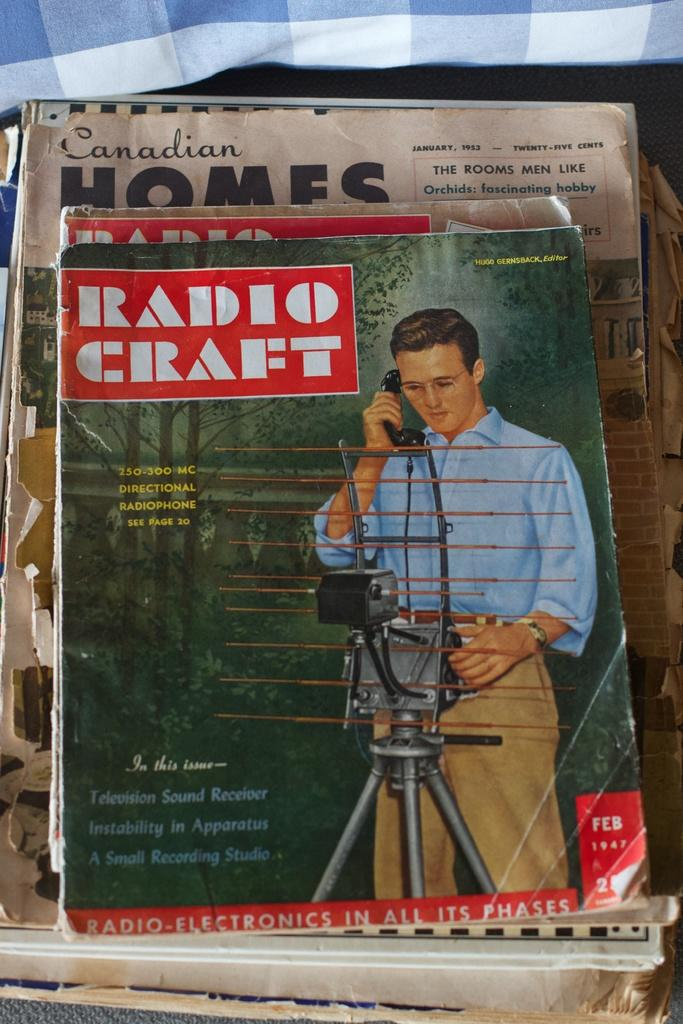<image>
Render a clear and concise summary of the photo. Cover of an old magazine made by Radio Craft 